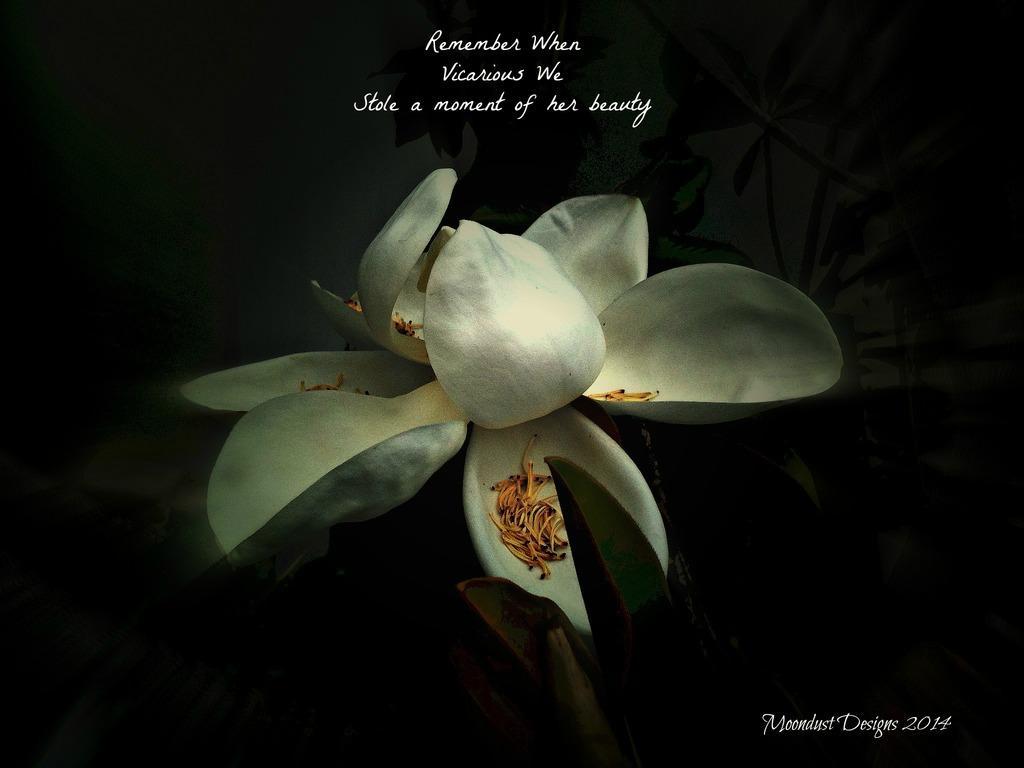In one or two sentences, can you explain what this image depicts? In this picture I can see the flower plant and text. 